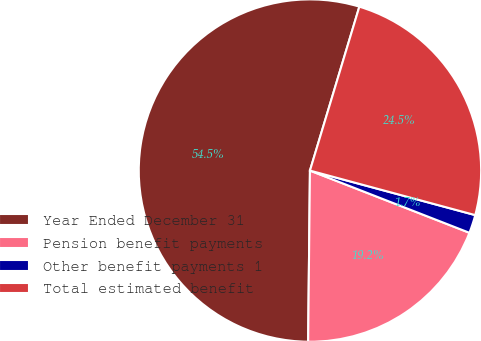Convert chart to OTSL. <chart><loc_0><loc_0><loc_500><loc_500><pie_chart><fcel>Year Ended December 31<fcel>Pension benefit payments<fcel>Other benefit payments 1<fcel>Total estimated benefit<nl><fcel>54.49%<fcel>19.25%<fcel>1.73%<fcel>24.53%<nl></chart> 